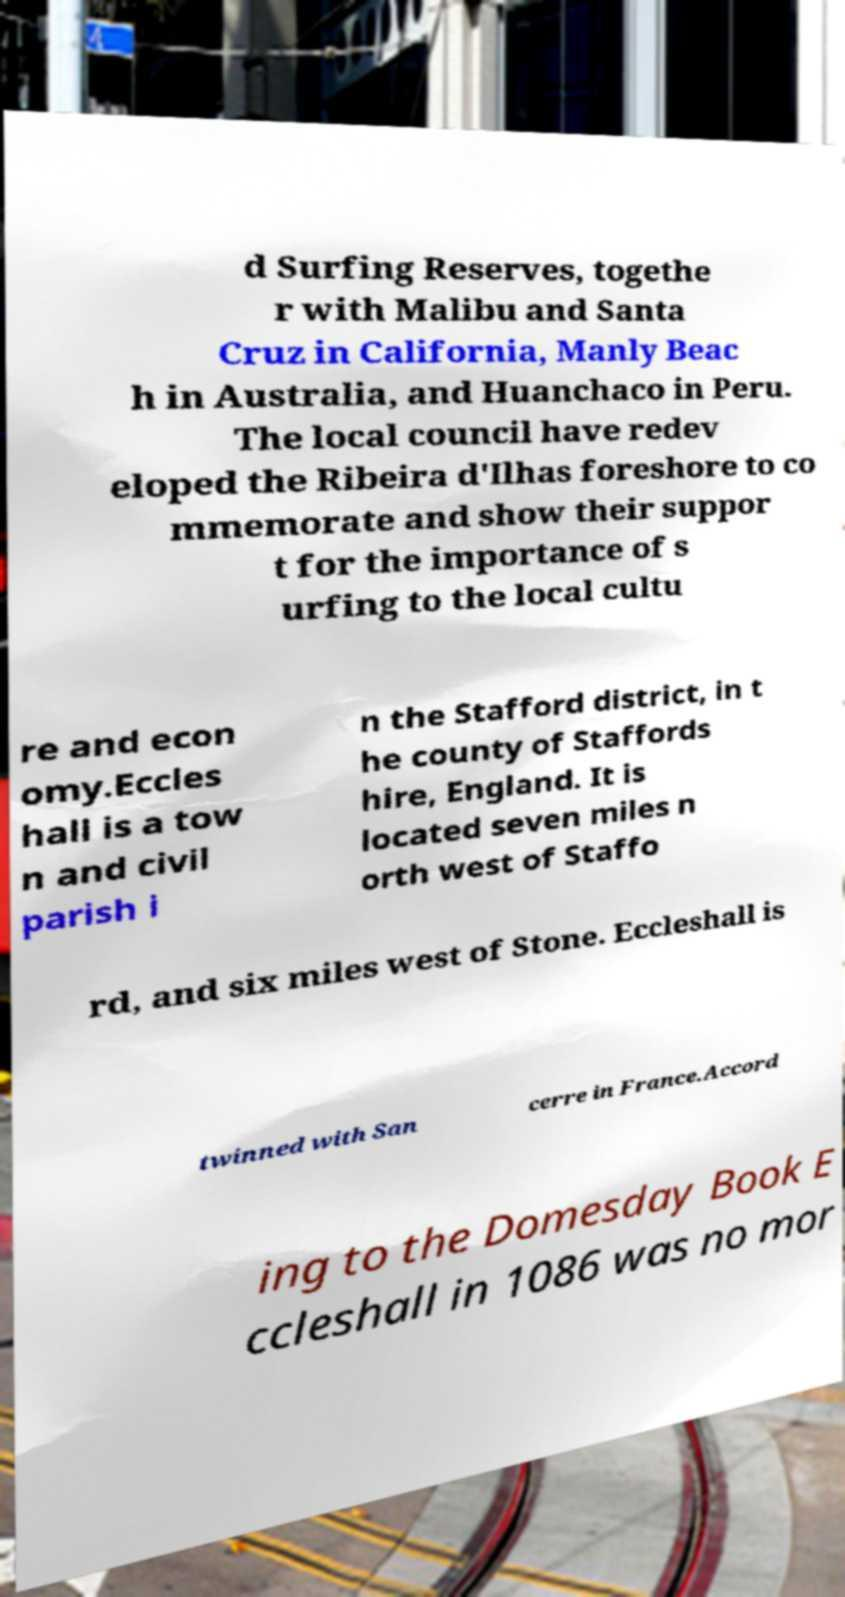What messages or text are displayed in this image? I need them in a readable, typed format. d Surfing Reserves, togethe r with Malibu and Santa Cruz in California, Manly Beac h in Australia, and Huanchaco in Peru. The local council have redev eloped the Ribeira d'Ilhas foreshore to co mmemorate and show their suppor t for the importance of s urfing to the local cultu re and econ omy.Eccles hall is a tow n and civil parish i n the Stafford district, in t he county of Staffords hire, England. It is located seven miles n orth west of Staffo rd, and six miles west of Stone. Eccleshall is twinned with San cerre in France.Accord ing to the Domesday Book E ccleshall in 1086 was no mor 